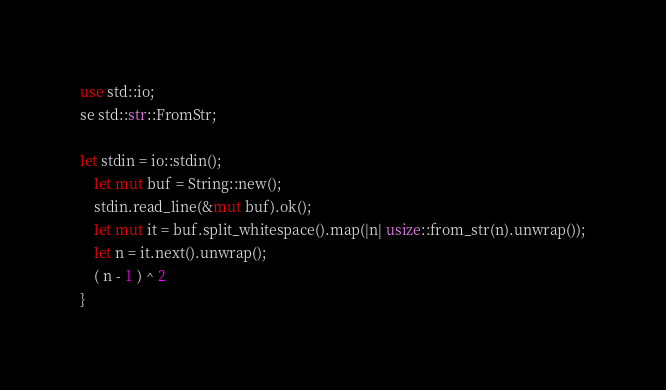Convert code to text. <code><loc_0><loc_0><loc_500><loc_500><_Rust_>use std::io;
se std::str::FromStr;

let stdin = io::stdin();
    let mut buf = String::new();
    stdin.read_line(&mut buf).ok();
    let mut it = buf.split_whitespace().map(|n| usize::from_str(n).unwrap());
    let n = it.next().unwrap();
    ( n - 1 ) ^ 2
}</code> 